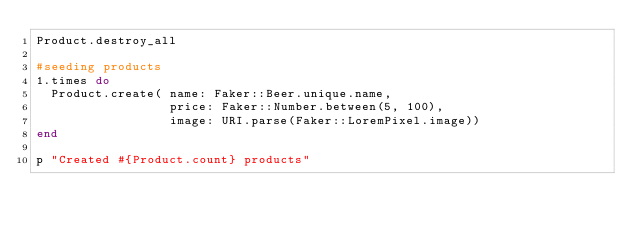Convert code to text. <code><loc_0><loc_0><loc_500><loc_500><_Ruby_>Product.destroy_all

#seeding products
1.times do
  Product.create( name: Faker::Beer.unique.name,
                  price: Faker::Number.between(5, 100),
                  image: URI.parse(Faker::LoremPixel.image))
end

p "Created #{Product.count} products"
</code> 